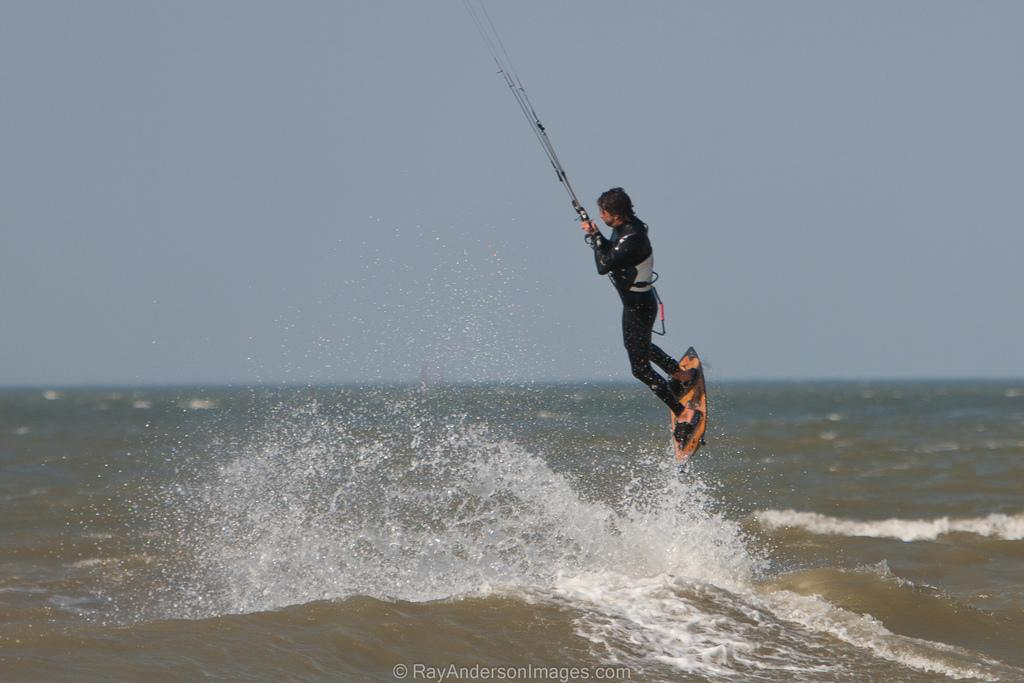Who is present in the image? There is a person in the image. What is the person holding in the image? The person is holding a surfboard and ropes. What can be seen in the image besides the person and their belongings? There is water visible in the image. What is visible in the background of the image? The sky is visible in the background of the image. What type of feast is being prepared on the sand in the image? There is no feast or sand present in the image; it features a person holding a surfboard and ropes near water. 